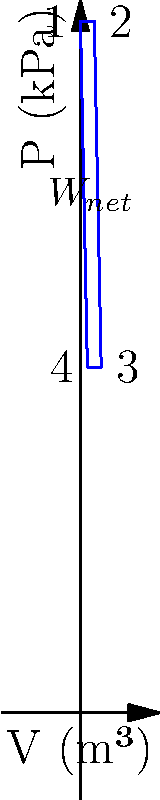A heat engine operates on the cycle shown in the P-V diagram. If the heat input during the constant pressure process 1-2 is 800 kJ and the heat rejected during the constant pressure process 3-4 is 500 kJ, calculate the thermal efficiency of this heat engine. To calculate the thermal efficiency of a heat engine, we need to follow these steps:

1. Recall the formula for thermal efficiency:
   $$\eta = \frac{W_{net}}{Q_{in}}$$
   where $\eta$ is the thermal efficiency, $W_{net}$ is the net work done, and $Q_{in}$ is the heat input.

2. We are given:
   $Q_{in}$ (heat input during process 1-2) = 800 kJ
   $Q_{out}$ (heat rejected during process 3-4) = 500 kJ

3. Calculate the net work done:
   $$W_{net} = Q_{in} - Q_{out} = 800 \text{ kJ} - 500 \text{ kJ} = 300 \text{ kJ}$$

4. Now we can calculate the thermal efficiency:
   $$\eta = \frac{W_{net}}{Q_{in}} = \frac{300 \text{ kJ}}{800 \text{ kJ}} = 0.375$$

5. Convert to percentage:
   $$\eta = 0.375 \times 100\% = 37.5\%$$

Therefore, the thermal efficiency of this heat engine is 37.5%.
Answer: 37.5% 